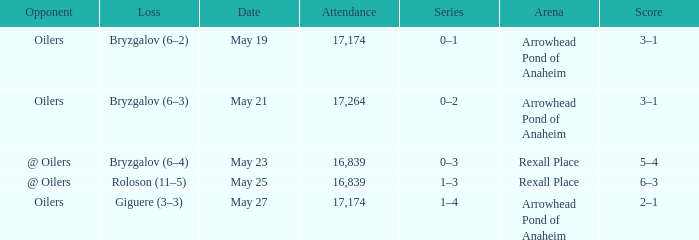Help me parse the entirety of this table. {'header': ['Opponent', 'Loss', 'Date', 'Attendance', 'Series', 'Arena', 'Score'], 'rows': [['Oilers', 'Bryzgalov (6–2)', 'May 19', '17,174', '0–1', 'Arrowhead Pond of Anaheim', '3–1'], ['Oilers', 'Bryzgalov (6–3)', 'May 21', '17,264', '0–2', 'Arrowhead Pond of Anaheim', '3–1'], ['@ Oilers', 'Bryzgalov (6–4)', 'May 23', '16,839', '0–3', 'Rexall Place', '5–4'], ['@ Oilers', 'Roloson (11–5)', 'May 25', '16,839', '1–3', 'Rexall Place', '6–3'], ['Oilers', 'Giguere (3–3)', 'May 27', '17,174', '1–4', 'Arrowhead Pond of Anaheim', '2–1']]} Which Arena has an Opponent of @ oilers, and a Date of may 25? Rexall Place. 